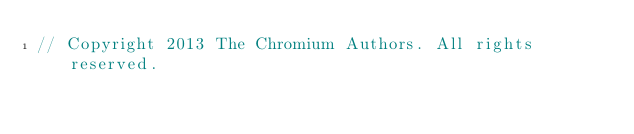<code> <loc_0><loc_0><loc_500><loc_500><_C++_>// Copyright 2013 The Chromium Authors. All rights reserved.</code> 